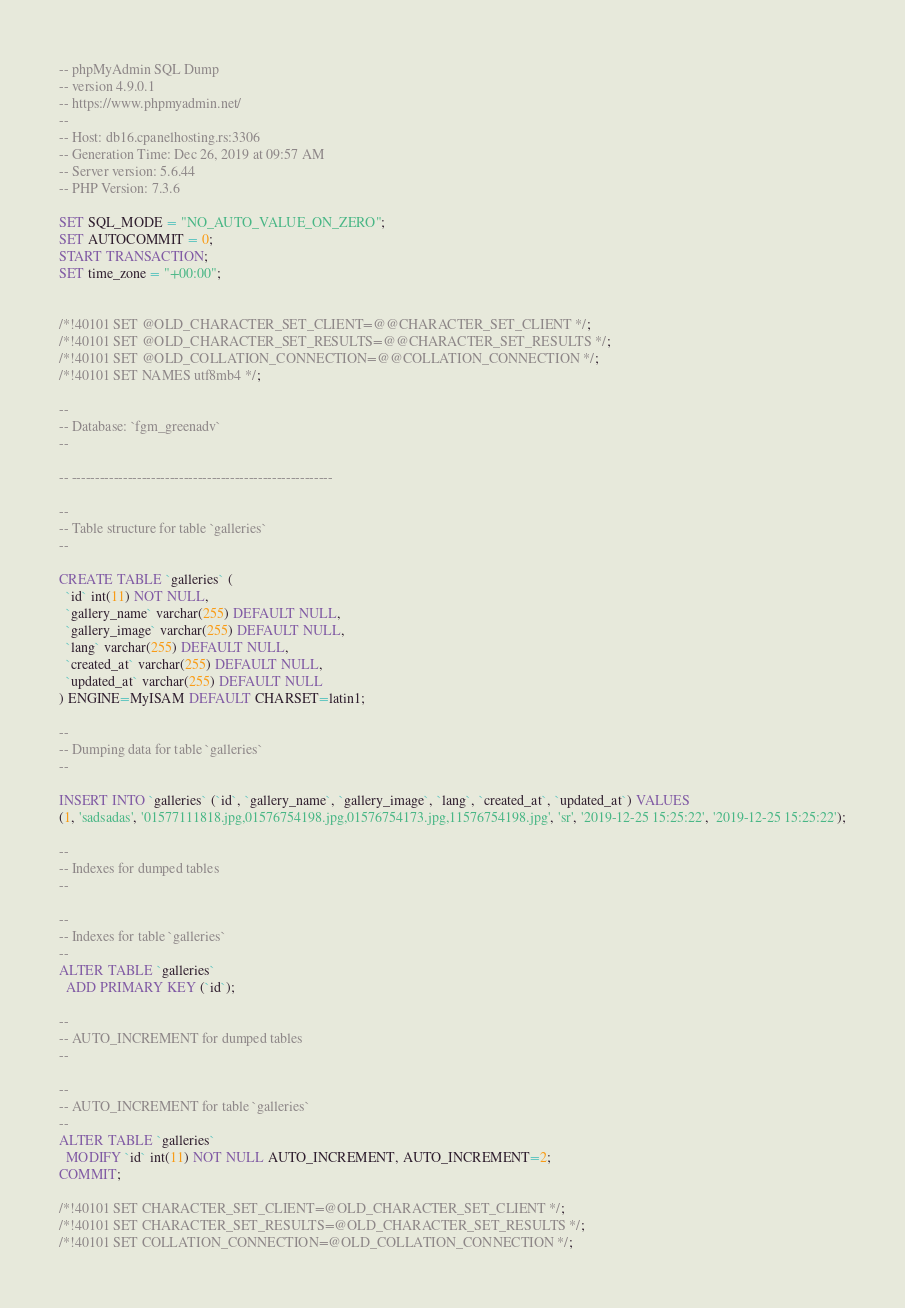Convert code to text. <code><loc_0><loc_0><loc_500><loc_500><_SQL_>-- phpMyAdmin SQL Dump
-- version 4.9.0.1
-- https://www.phpmyadmin.net/
--
-- Host: db16.cpanelhosting.rs:3306
-- Generation Time: Dec 26, 2019 at 09:57 AM
-- Server version: 5.6.44
-- PHP Version: 7.3.6

SET SQL_MODE = "NO_AUTO_VALUE_ON_ZERO";
SET AUTOCOMMIT = 0;
START TRANSACTION;
SET time_zone = "+00:00";


/*!40101 SET @OLD_CHARACTER_SET_CLIENT=@@CHARACTER_SET_CLIENT */;
/*!40101 SET @OLD_CHARACTER_SET_RESULTS=@@CHARACTER_SET_RESULTS */;
/*!40101 SET @OLD_COLLATION_CONNECTION=@@COLLATION_CONNECTION */;
/*!40101 SET NAMES utf8mb4 */;

--
-- Database: `fgm_greenadv`
--

-- --------------------------------------------------------

--
-- Table structure for table `galleries`
--

CREATE TABLE `galleries` (
  `id` int(11) NOT NULL,
  `gallery_name` varchar(255) DEFAULT NULL,
  `gallery_image` varchar(255) DEFAULT NULL,
  `lang` varchar(255) DEFAULT NULL,
  `created_at` varchar(255) DEFAULT NULL,
  `updated_at` varchar(255) DEFAULT NULL
) ENGINE=MyISAM DEFAULT CHARSET=latin1;

--
-- Dumping data for table `galleries`
--

INSERT INTO `galleries` (`id`, `gallery_name`, `gallery_image`, `lang`, `created_at`, `updated_at`) VALUES
(1, 'sadsadas', '01577111818.jpg,01576754198.jpg,01576754173.jpg,11576754198.jpg', 'sr', '2019-12-25 15:25:22', '2019-12-25 15:25:22');

--
-- Indexes for dumped tables
--

--
-- Indexes for table `galleries`
--
ALTER TABLE `galleries`
  ADD PRIMARY KEY (`id`);

--
-- AUTO_INCREMENT for dumped tables
--

--
-- AUTO_INCREMENT for table `galleries`
--
ALTER TABLE `galleries`
  MODIFY `id` int(11) NOT NULL AUTO_INCREMENT, AUTO_INCREMENT=2;
COMMIT;

/*!40101 SET CHARACTER_SET_CLIENT=@OLD_CHARACTER_SET_CLIENT */;
/*!40101 SET CHARACTER_SET_RESULTS=@OLD_CHARACTER_SET_RESULTS */;
/*!40101 SET COLLATION_CONNECTION=@OLD_COLLATION_CONNECTION */;
</code> 